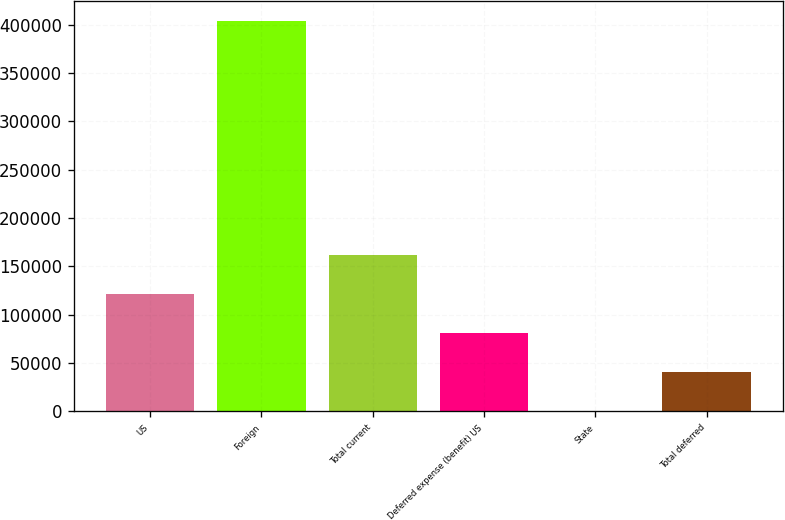Convert chart. <chart><loc_0><loc_0><loc_500><loc_500><bar_chart><fcel>US<fcel>Foreign<fcel>Total current<fcel>Deferred expense (benefit) US<fcel>State<fcel>Total deferred<nl><fcel>121883<fcel>404109<fcel>162201<fcel>81565<fcel>929<fcel>41247<nl></chart> 